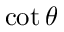Convert formula to latex. <formula><loc_0><loc_0><loc_500><loc_500>\cot \theta</formula> 